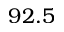Convert formula to latex. <formula><loc_0><loc_0><loc_500><loc_500>9 2 . 5</formula> 